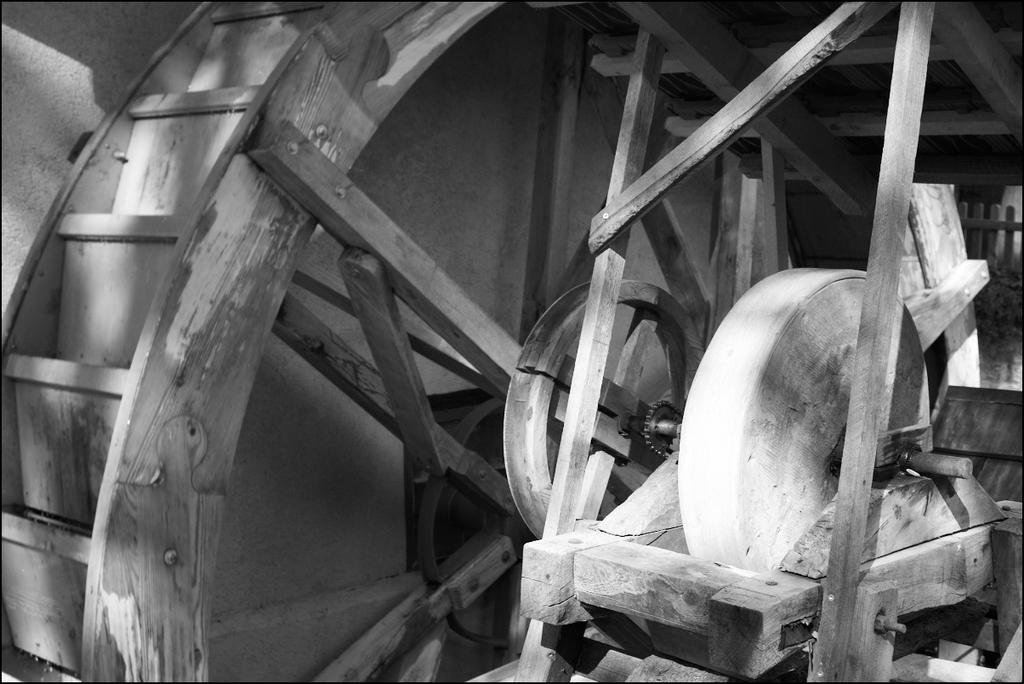What type of material is the object in the image made of? The wooden object in the image is made of wood. What is the background of the image? There is a wall in the image. What can be seen on the right side of the image? There is a fence on the right side of the image. What is the title of the book that the person is reading in the image? There is no person or book present in the image, so there is no title to provide. 